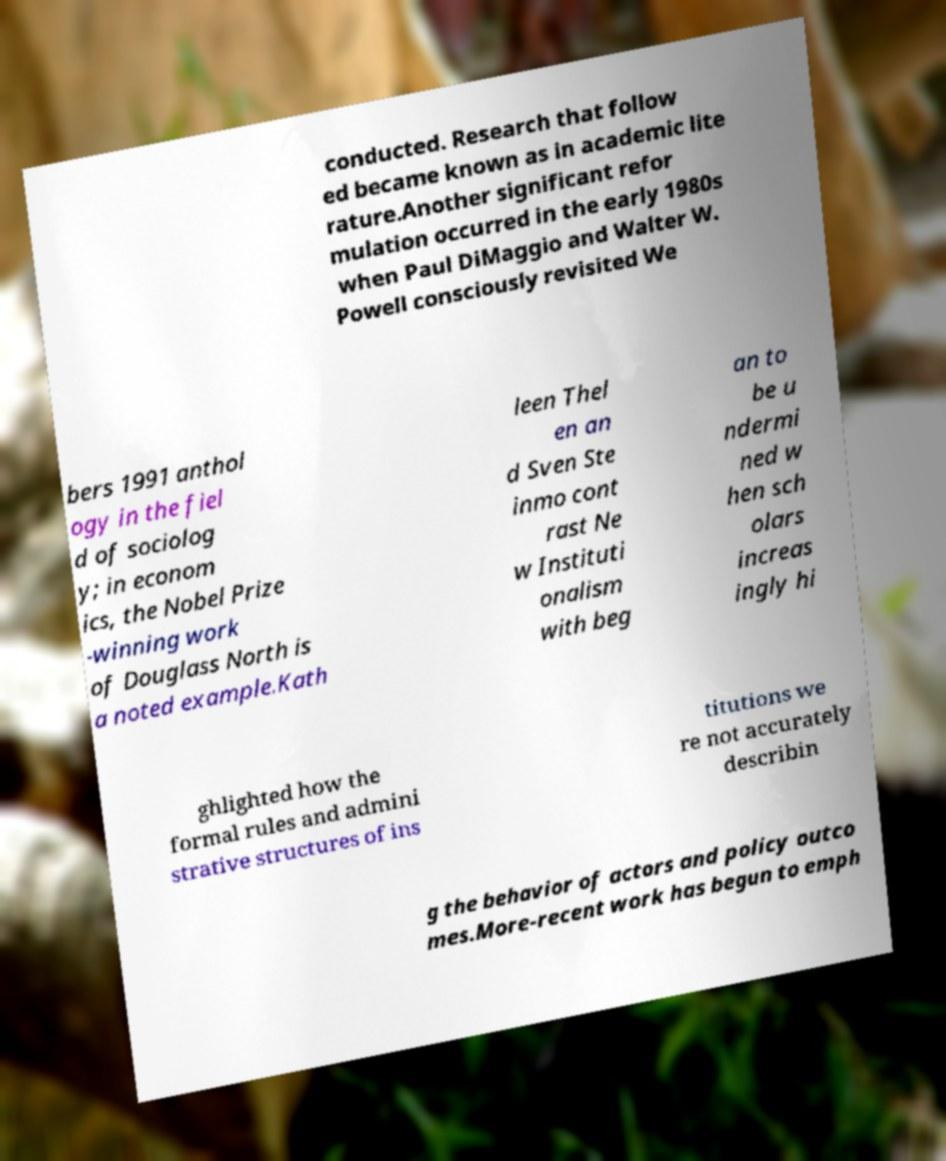There's text embedded in this image that I need extracted. Can you transcribe it verbatim? conducted. Research that follow ed became known as in academic lite rature.Another significant refor mulation occurred in the early 1980s when Paul DiMaggio and Walter W. Powell consciously revisited We bers 1991 anthol ogy in the fiel d of sociolog y; in econom ics, the Nobel Prize -winning work of Douglass North is a noted example.Kath leen Thel en an d Sven Ste inmo cont rast Ne w Instituti onalism with beg an to be u ndermi ned w hen sch olars increas ingly hi ghlighted how the formal rules and admini strative structures of ins titutions we re not accurately describin g the behavior of actors and policy outco mes.More-recent work has begun to emph 